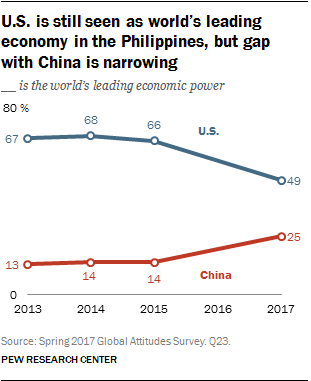Specify some key components in this picture. In China, the years with a value of 14 are considered valuable. The rightmost value of the red graph is 25. 